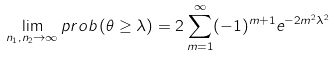Convert formula to latex. <formula><loc_0><loc_0><loc_500><loc_500>\lim _ { n _ { 1 } , n _ { 2 } \rightarrow \infty } p r o b \left ( \theta \geq \lambda \right ) = 2 \sum _ { m = 1 } ^ { \infty } ( - 1 ) ^ { m + 1 } e ^ { - 2 m ^ { 2 } \lambda ^ { 2 } }</formula> 